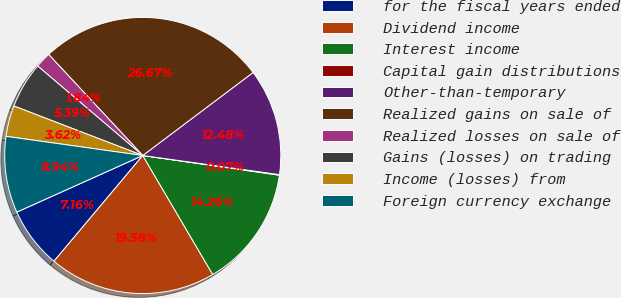Convert chart. <chart><loc_0><loc_0><loc_500><loc_500><pie_chart><fcel>for the fiscal years ended<fcel>Dividend income<fcel>Interest income<fcel>Capital gain distributions<fcel>Other-than-temporary<fcel>Realized gains on sale of<fcel>Realized losses on sale of<fcel>Gains (losses) on trading<fcel>Income (losses) from<fcel>Foreign currency exchange<nl><fcel>7.16%<fcel>19.58%<fcel>14.26%<fcel>0.07%<fcel>12.48%<fcel>26.67%<fcel>1.84%<fcel>5.39%<fcel>3.62%<fcel>8.94%<nl></chart> 